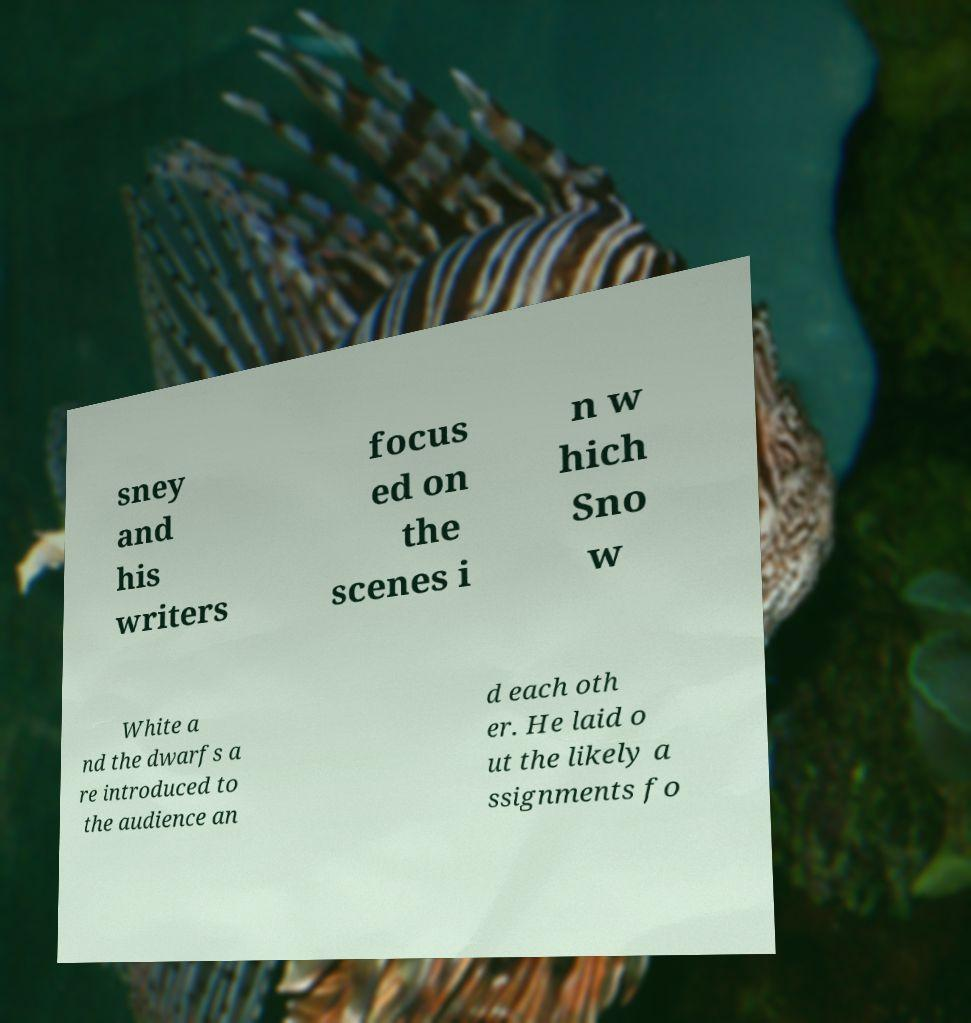Could you extract and type out the text from this image? sney and his writers focus ed on the scenes i n w hich Sno w White a nd the dwarfs a re introduced to the audience an d each oth er. He laid o ut the likely a ssignments fo 